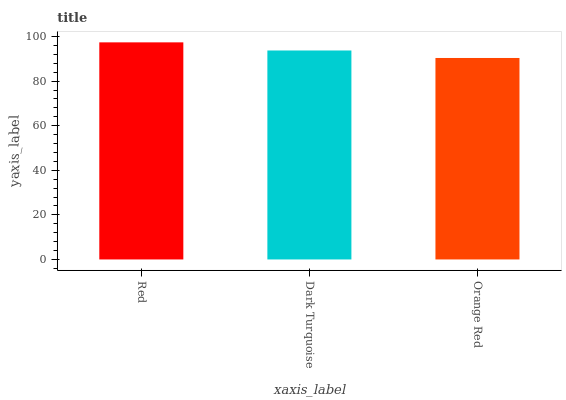Is Orange Red the minimum?
Answer yes or no. Yes. Is Red the maximum?
Answer yes or no. Yes. Is Dark Turquoise the minimum?
Answer yes or no. No. Is Dark Turquoise the maximum?
Answer yes or no. No. Is Red greater than Dark Turquoise?
Answer yes or no. Yes. Is Dark Turquoise less than Red?
Answer yes or no. Yes. Is Dark Turquoise greater than Red?
Answer yes or no. No. Is Red less than Dark Turquoise?
Answer yes or no. No. Is Dark Turquoise the high median?
Answer yes or no. Yes. Is Dark Turquoise the low median?
Answer yes or no. Yes. Is Orange Red the high median?
Answer yes or no. No. Is Orange Red the low median?
Answer yes or no. No. 